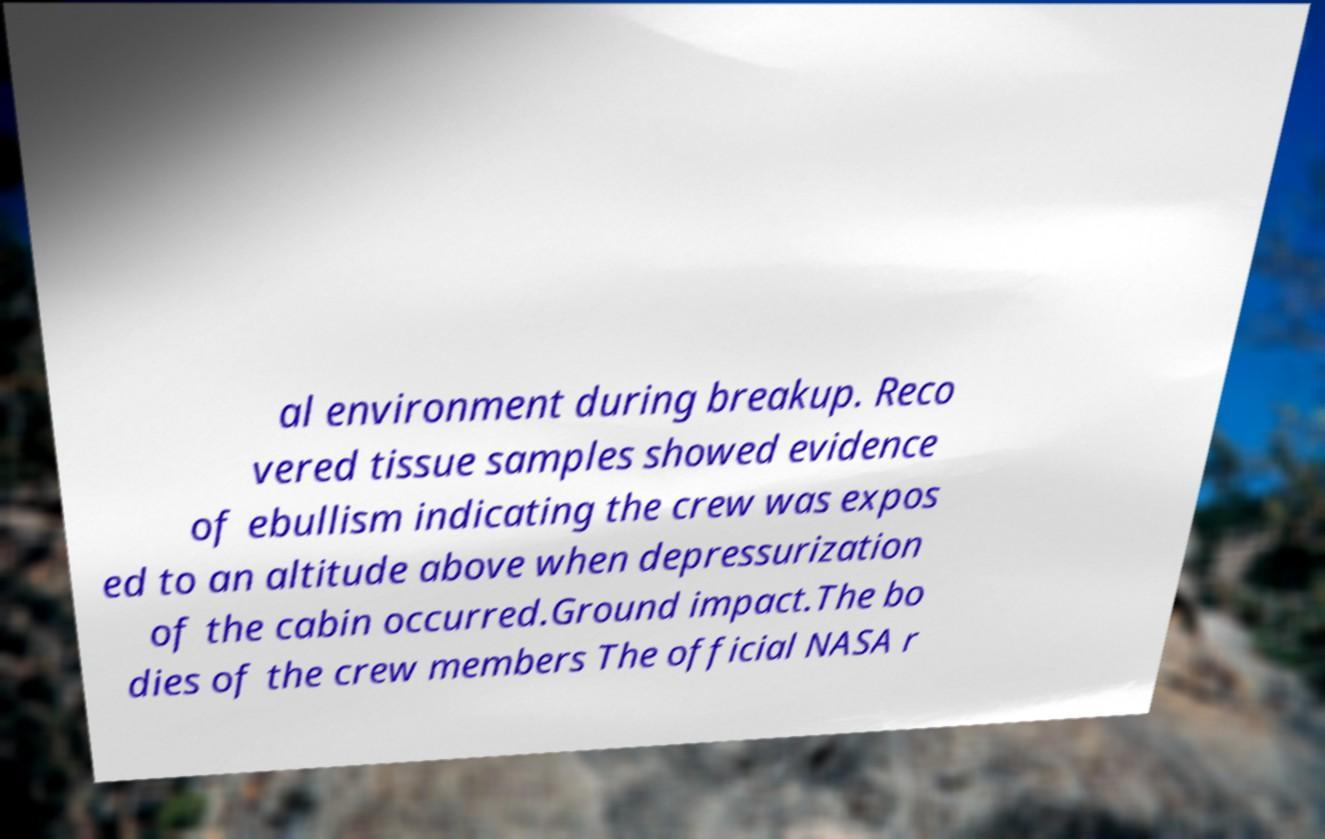Please identify and transcribe the text found in this image. al environment during breakup. Reco vered tissue samples showed evidence of ebullism indicating the crew was expos ed to an altitude above when depressurization of the cabin occurred.Ground impact.The bo dies of the crew members The official NASA r 